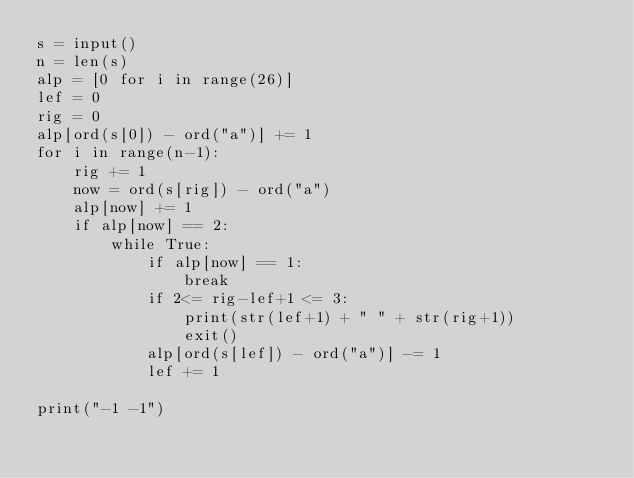<code> <loc_0><loc_0><loc_500><loc_500><_Python_>s = input()
n = len(s)
alp = [0 for i in range(26)]
lef = 0
rig = 0
alp[ord(s[0]) - ord("a")] += 1
for i in range(n-1):
    rig += 1
    now = ord(s[rig]) - ord("a")
    alp[now] += 1
    if alp[now] == 2:
        while True:
            if alp[now] == 1:
                break
            if 2<= rig-lef+1 <= 3:
                print(str(lef+1) + " " + str(rig+1))
                exit()
            alp[ord(s[lef]) - ord("a")] -= 1
            lef += 1
                
print("-1 -1")</code> 